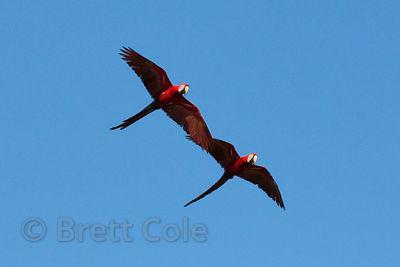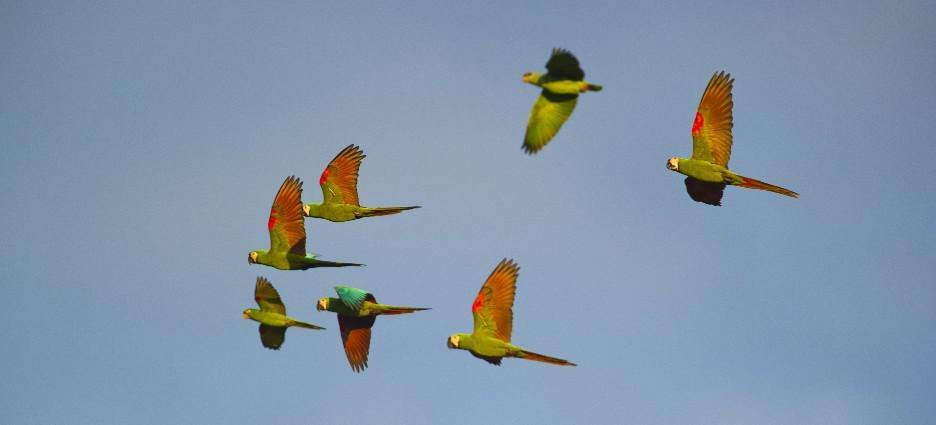The first image is the image on the left, the second image is the image on the right. For the images displayed, is the sentence "Two birds are flying the air in the image on the left" factually correct? Answer yes or no. Yes. The first image is the image on the left, the second image is the image on the right. Assess this claim about the two images: "The left photo depicts only two parrots.". Correct or not? Answer yes or no. Yes. 